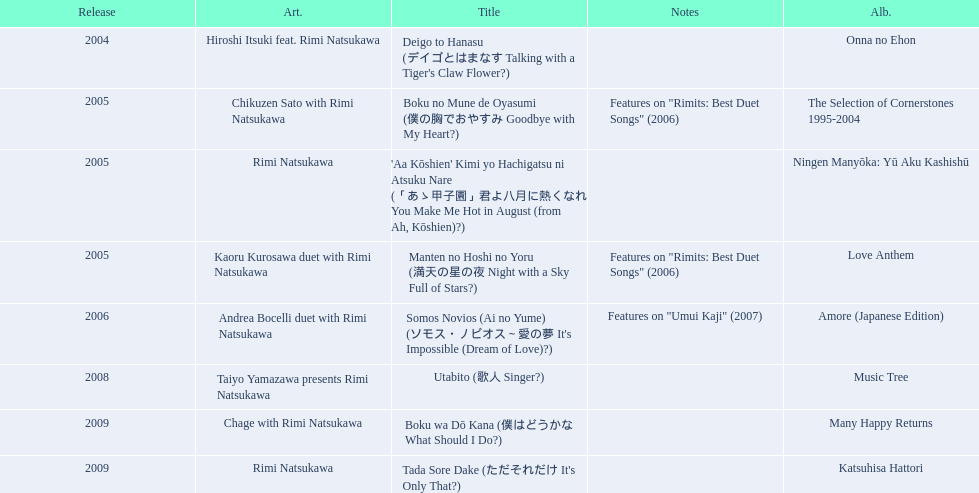Which title of the rimi natsukawa discography was released in the 2004? Deigo to Hanasu (デイゴとはまなす Talking with a Tiger's Claw Flower?). Which title has notes that features on/rimits. best duet songs\2006 Manten no Hoshi no Yoru (満天の星の夜 Night with a Sky Full of Stars?). Which title share the same notes as night with a sky full of stars? Boku no Mune de Oyasumi (僕の胸でおやすみ Goodbye with My Heart?). 